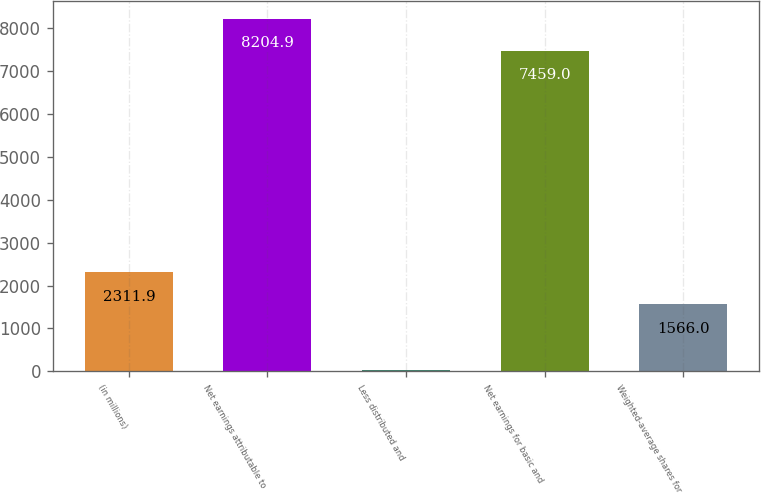<chart> <loc_0><loc_0><loc_500><loc_500><bar_chart><fcel>(in millions)<fcel>Net earnings attributable to<fcel>Less distributed and<fcel>Net earnings for basic and<fcel>Weighted-average shares for<nl><fcel>2311.9<fcel>8204.9<fcel>34<fcel>7459<fcel>1566<nl></chart> 